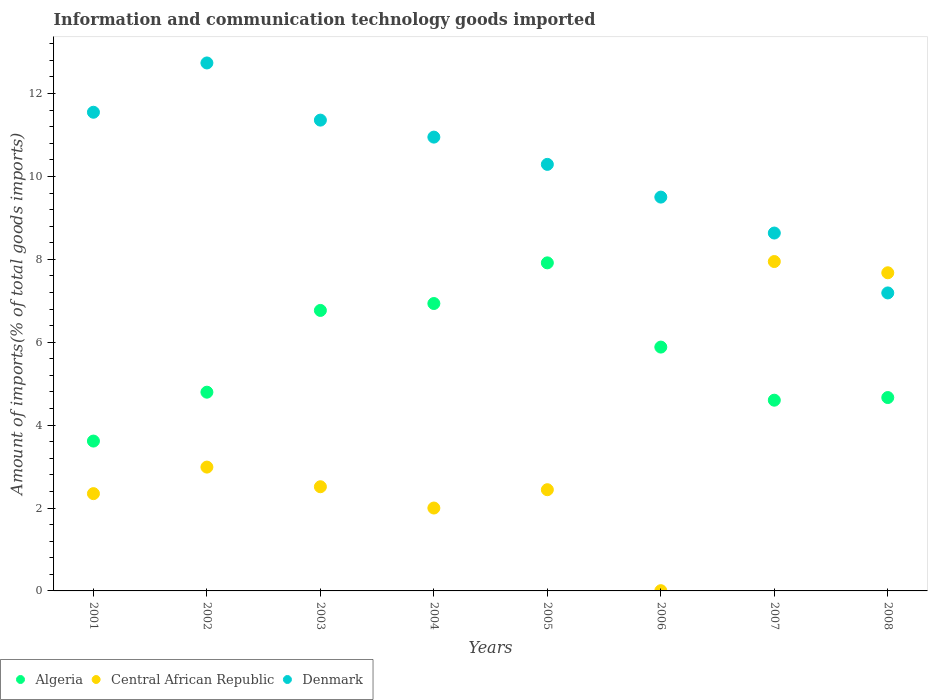How many different coloured dotlines are there?
Provide a succinct answer. 3. What is the amount of goods imported in Central African Republic in 2003?
Make the answer very short. 2.51. Across all years, what is the maximum amount of goods imported in Denmark?
Ensure brevity in your answer.  12.74. Across all years, what is the minimum amount of goods imported in Denmark?
Offer a terse response. 7.19. In which year was the amount of goods imported in Denmark maximum?
Your response must be concise. 2002. What is the total amount of goods imported in Central African Republic in the graph?
Keep it short and to the point. 27.92. What is the difference between the amount of goods imported in Denmark in 2003 and that in 2007?
Make the answer very short. 2.72. What is the difference between the amount of goods imported in Denmark in 2006 and the amount of goods imported in Central African Republic in 2001?
Provide a short and direct response. 7.15. What is the average amount of goods imported in Algeria per year?
Your response must be concise. 5.65. In the year 2004, what is the difference between the amount of goods imported in Denmark and amount of goods imported in Central African Republic?
Your answer should be compact. 8.95. In how many years, is the amount of goods imported in Central African Republic greater than 10.4 %?
Offer a very short reply. 0. What is the ratio of the amount of goods imported in Denmark in 2004 to that in 2006?
Provide a short and direct response. 1.15. Is the amount of goods imported in Denmark in 2002 less than that in 2007?
Your answer should be very brief. No. Is the difference between the amount of goods imported in Denmark in 2006 and 2008 greater than the difference between the amount of goods imported in Central African Republic in 2006 and 2008?
Provide a short and direct response. Yes. What is the difference between the highest and the second highest amount of goods imported in Central African Republic?
Make the answer very short. 0.27. What is the difference between the highest and the lowest amount of goods imported in Algeria?
Your answer should be very brief. 4.3. Is the amount of goods imported in Central African Republic strictly greater than the amount of goods imported in Algeria over the years?
Your answer should be very brief. No. Is the amount of goods imported in Algeria strictly less than the amount of goods imported in Denmark over the years?
Give a very brief answer. Yes. How many years are there in the graph?
Offer a very short reply. 8. Does the graph contain any zero values?
Your answer should be compact. No. How many legend labels are there?
Provide a succinct answer. 3. How are the legend labels stacked?
Offer a terse response. Horizontal. What is the title of the graph?
Your response must be concise. Information and communication technology goods imported. What is the label or title of the Y-axis?
Keep it short and to the point. Amount of imports(% of total goods imports). What is the Amount of imports(% of total goods imports) of Algeria in 2001?
Give a very brief answer. 3.62. What is the Amount of imports(% of total goods imports) in Central African Republic in 2001?
Offer a very short reply. 2.35. What is the Amount of imports(% of total goods imports) of Denmark in 2001?
Provide a short and direct response. 11.55. What is the Amount of imports(% of total goods imports) in Algeria in 2002?
Provide a succinct answer. 4.79. What is the Amount of imports(% of total goods imports) in Central African Republic in 2002?
Make the answer very short. 2.99. What is the Amount of imports(% of total goods imports) in Denmark in 2002?
Ensure brevity in your answer.  12.74. What is the Amount of imports(% of total goods imports) of Algeria in 2003?
Give a very brief answer. 6.77. What is the Amount of imports(% of total goods imports) in Central African Republic in 2003?
Keep it short and to the point. 2.51. What is the Amount of imports(% of total goods imports) of Denmark in 2003?
Keep it short and to the point. 11.36. What is the Amount of imports(% of total goods imports) in Algeria in 2004?
Your answer should be compact. 6.93. What is the Amount of imports(% of total goods imports) of Central African Republic in 2004?
Ensure brevity in your answer.  2. What is the Amount of imports(% of total goods imports) of Denmark in 2004?
Offer a very short reply. 10.95. What is the Amount of imports(% of total goods imports) of Algeria in 2005?
Provide a succinct answer. 7.92. What is the Amount of imports(% of total goods imports) in Central African Republic in 2005?
Give a very brief answer. 2.44. What is the Amount of imports(% of total goods imports) in Denmark in 2005?
Keep it short and to the point. 10.29. What is the Amount of imports(% of total goods imports) in Algeria in 2006?
Make the answer very short. 5.88. What is the Amount of imports(% of total goods imports) in Central African Republic in 2006?
Offer a very short reply. 0.01. What is the Amount of imports(% of total goods imports) of Denmark in 2006?
Provide a short and direct response. 9.5. What is the Amount of imports(% of total goods imports) in Algeria in 2007?
Offer a terse response. 4.6. What is the Amount of imports(% of total goods imports) of Central African Republic in 2007?
Offer a terse response. 7.95. What is the Amount of imports(% of total goods imports) of Denmark in 2007?
Your answer should be compact. 8.63. What is the Amount of imports(% of total goods imports) of Algeria in 2008?
Make the answer very short. 4.67. What is the Amount of imports(% of total goods imports) of Central African Republic in 2008?
Ensure brevity in your answer.  7.68. What is the Amount of imports(% of total goods imports) of Denmark in 2008?
Keep it short and to the point. 7.19. Across all years, what is the maximum Amount of imports(% of total goods imports) of Algeria?
Ensure brevity in your answer.  7.92. Across all years, what is the maximum Amount of imports(% of total goods imports) in Central African Republic?
Offer a terse response. 7.95. Across all years, what is the maximum Amount of imports(% of total goods imports) of Denmark?
Your answer should be very brief. 12.74. Across all years, what is the minimum Amount of imports(% of total goods imports) of Algeria?
Make the answer very short. 3.62. Across all years, what is the minimum Amount of imports(% of total goods imports) in Central African Republic?
Your answer should be compact. 0.01. Across all years, what is the minimum Amount of imports(% of total goods imports) of Denmark?
Your answer should be very brief. 7.19. What is the total Amount of imports(% of total goods imports) in Algeria in the graph?
Ensure brevity in your answer.  45.18. What is the total Amount of imports(% of total goods imports) of Central African Republic in the graph?
Offer a terse response. 27.92. What is the total Amount of imports(% of total goods imports) in Denmark in the graph?
Your response must be concise. 82.21. What is the difference between the Amount of imports(% of total goods imports) in Algeria in 2001 and that in 2002?
Make the answer very short. -1.18. What is the difference between the Amount of imports(% of total goods imports) in Central African Republic in 2001 and that in 2002?
Ensure brevity in your answer.  -0.64. What is the difference between the Amount of imports(% of total goods imports) of Denmark in 2001 and that in 2002?
Keep it short and to the point. -1.19. What is the difference between the Amount of imports(% of total goods imports) of Algeria in 2001 and that in 2003?
Your answer should be compact. -3.15. What is the difference between the Amount of imports(% of total goods imports) in Central African Republic in 2001 and that in 2003?
Offer a very short reply. -0.17. What is the difference between the Amount of imports(% of total goods imports) of Denmark in 2001 and that in 2003?
Provide a succinct answer. 0.19. What is the difference between the Amount of imports(% of total goods imports) in Algeria in 2001 and that in 2004?
Make the answer very short. -3.32. What is the difference between the Amount of imports(% of total goods imports) of Central African Republic in 2001 and that in 2004?
Offer a terse response. 0.35. What is the difference between the Amount of imports(% of total goods imports) in Denmark in 2001 and that in 2004?
Your response must be concise. 0.6. What is the difference between the Amount of imports(% of total goods imports) of Algeria in 2001 and that in 2005?
Keep it short and to the point. -4.3. What is the difference between the Amount of imports(% of total goods imports) of Central African Republic in 2001 and that in 2005?
Ensure brevity in your answer.  -0.09. What is the difference between the Amount of imports(% of total goods imports) of Denmark in 2001 and that in 2005?
Your response must be concise. 1.26. What is the difference between the Amount of imports(% of total goods imports) in Algeria in 2001 and that in 2006?
Your answer should be very brief. -2.27. What is the difference between the Amount of imports(% of total goods imports) of Central African Republic in 2001 and that in 2006?
Keep it short and to the point. 2.34. What is the difference between the Amount of imports(% of total goods imports) in Denmark in 2001 and that in 2006?
Your answer should be very brief. 2.05. What is the difference between the Amount of imports(% of total goods imports) of Algeria in 2001 and that in 2007?
Offer a very short reply. -0.99. What is the difference between the Amount of imports(% of total goods imports) of Central African Republic in 2001 and that in 2007?
Ensure brevity in your answer.  -5.6. What is the difference between the Amount of imports(% of total goods imports) in Denmark in 2001 and that in 2007?
Make the answer very short. 2.91. What is the difference between the Amount of imports(% of total goods imports) in Algeria in 2001 and that in 2008?
Offer a terse response. -1.05. What is the difference between the Amount of imports(% of total goods imports) of Central African Republic in 2001 and that in 2008?
Offer a very short reply. -5.33. What is the difference between the Amount of imports(% of total goods imports) in Denmark in 2001 and that in 2008?
Make the answer very short. 4.36. What is the difference between the Amount of imports(% of total goods imports) in Algeria in 2002 and that in 2003?
Offer a very short reply. -1.97. What is the difference between the Amount of imports(% of total goods imports) in Central African Republic in 2002 and that in 2003?
Keep it short and to the point. 0.47. What is the difference between the Amount of imports(% of total goods imports) in Denmark in 2002 and that in 2003?
Offer a terse response. 1.38. What is the difference between the Amount of imports(% of total goods imports) in Algeria in 2002 and that in 2004?
Give a very brief answer. -2.14. What is the difference between the Amount of imports(% of total goods imports) in Central African Republic in 2002 and that in 2004?
Your answer should be compact. 0.99. What is the difference between the Amount of imports(% of total goods imports) in Denmark in 2002 and that in 2004?
Offer a terse response. 1.79. What is the difference between the Amount of imports(% of total goods imports) of Algeria in 2002 and that in 2005?
Offer a very short reply. -3.12. What is the difference between the Amount of imports(% of total goods imports) in Central African Republic in 2002 and that in 2005?
Ensure brevity in your answer.  0.55. What is the difference between the Amount of imports(% of total goods imports) in Denmark in 2002 and that in 2005?
Provide a short and direct response. 2.45. What is the difference between the Amount of imports(% of total goods imports) of Algeria in 2002 and that in 2006?
Your answer should be compact. -1.09. What is the difference between the Amount of imports(% of total goods imports) in Central African Republic in 2002 and that in 2006?
Your answer should be very brief. 2.98. What is the difference between the Amount of imports(% of total goods imports) in Denmark in 2002 and that in 2006?
Ensure brevity in your answer.  3.24. What is the difference between the Amount of imports(% of total goods imports) in Algeria in 2002 and that in 2007?
Provide a succinct answer. 0.19. What is the difference between the Amount of imports(% of total goods imports) in Central African Republic in 2002 and that in 2007?
Ensure brevity in your answer.  -4.96. What is the difference between the Amount of imports(% of total goods imports) of Denmark in 2002 and that in 2007?
Your answer should be compact. 4.1. What is the difference between the Amount of imports(% of total goods imports) of Algeria in 2002 and that in 2008?
Ensure brevity in your answer.  0.13. What is the difference between the Amount of imports(% of total goods imports) of Central African Republic in 2002 and that in 2008?
Provide a short and direct response. -4.69. What is the difference between the Amount of imports(% of total goods imports) of Denmark in 2002 and that in 2008?
Make the answer very short. 5.55. What is the difference between the Amount of imports(% of total goods imports) of Algeria in 2003 and that in 2004?
Ensure brevity in your answer.  -0.17. What is the difference between the Amount of imports(% of total goods imports) in Central African Republic in 2003 and that in 2004?
Your answer should be very brief. 0.51. What is the difference between the Amount of imports(% of total goods imports) in Denmark in 2003 and that in 2004?
Keep it short and to the point. 0.41. What is the difference between the Amount of imports(% of total goods imports) in Algeria in 2003 and that in 2005?
Offer a very short reply. -1.15. What is the difference between the Amount of imports(% of total goods imports) in Central African Republic in 2003 and that in 2005?
Your answer should be very brief. 0.07. What is the difference between the Amount of imports(% of total goods imports) in Denmark in 2003 and that in 2005?
Your answer should be very brief. 1.07. What is the difference between the Amount of imports(% of total goods imports) in Algeria in 2003 and that in 2006?
Ensure brevity in your answer.  0.88. What is the difference between the Amount of imports(% of total goods imports) of Central African Republic in 2003 and that in 2006?
Offer a very short reply. 2.51. What is the difference between the Amount of imports(% of total goods imports) in Denmark in 2003 and that in 2006?
Ensure brevity in your answer.  1.86. What is the difference between the Amount of imports(% of total goods imports) of Algeria in 2003 and that in 2007?
Your response must be concise. 2.17. What is the difference between the Amount of imports(% of total goods imports) of Central African Republic in 2003 and that in 2007?
Give a very brief answer. -5.43. What is the difference between the Amount of imports(% of total goods imports) in Denmark in 2003 and that in 2007?
Make the answer very short. 2.72. What is the difference between the Amount of imports(% of total goods imports) of Algeria in 2003 and that in 2008?
Ensure brevity in your answer.  2.1. What is the difference between the Amount of imports(% of total goods imports) of Central African Republic in 2003 and that in 2008?
Give a very brief answer. -5.16. What is the difference between the Amount of imports(% of total goods imports) of Denmark in 2003 and that in 2008?
Make the answer very short. 4.17. What is the difference between the Amount of imports(% of total goods imports) in Algeria in 2004 and that in 2005?
Keep it short and to the point. -0.98. What is the difference between the Amount of imports(% of total goods imports) of Central African Republic in 2004 and that in 2005?
Keep it short and to the point. -0.44. What is the difference between the Amount of imports(% of total goods imports) of Denmark in 2004 and that in 2005?
Offer a very short reply. 0.66. What is the difference between the Amount of imports(% of total goods imports) of Algeria in 2004 and that in 2006?
Ensure brevity in your answer.  1.05. What is the difference between the Amount of imports(% of total goods imports) in Central African Republic in 2004 and that in 2006?
Offer a very short reply. 1.99. What is the difference between the Amount of imports(% of total goods imports) in Denmark in 2004 and that in 2006?
Provide a short and direct response. 1.45. What is the difference between the Amount of imports(% of total goods imports) of Algeria in 2004 and that in 2007?
Make the answer very short. 2.33. What is the difference between the Amount of imports(% of total goods imports) of Central African Republic in 2004 and that in 2007?
Your response must be concise. -5.95. What is the difference between the Amount of imports(% of total goods imports) of Denmark in 2004 and that in 2007?
Your response must be concise. 2.31. What is the difference between the Amount of imports(% of total goods imports) in Algeria in 2004 and that in 2008?
Your response must be concise. 2.27. What is the difference between the Amount of imports(% of total goods imports) in Central African Republic in 2004 and that in 2008?
Your answer should be very brief. -5.68. What is the difference between the Amount of imports(% of total goods imports) of Denmark in 2004 and that in 2008?
Offer a very short reply. 3.76. What is the difference between the Amount of imports(% of total goods imports) in Algeria in 2005 and that in 2006?
Ensure brevity in your answer.  2.03. What is the difference between the Amount of imports(% of total goods imports) in Central African Republic in 2005 and that in 2006?
Make the answer very short. 2.44. What is the difference between the Amount of imports(% of total goods imports) of Denmark in 2005 and that in 2006?
Give a very brief answer. 0.79. What is the difference between the Amount of imports(% of total goods imports) in Algeria in 2005 and that in 2007?
Your answer should be compact. 3.31. What is the difference between the Amount of imports(% of total goods imports) in Central African Republic in 2005 and that in 2007?
Provide a short and direct response. -5.51. What is the difference between the Amount of imports(% of total goods imports) in Denmark in 2005 and that in 2007?
Your answer should be very brief. 1.66. What is the difference between the Amount of imports(% of total goods imports) of Algeria in 2005 and that in 2008?
Make the answer very short. 3.25. What is the difference between the Amount of imports(% of total goods imports) of Central African Republic in 2005 and that in 2008?
Give a very brief answer. -5.23. What is the difference between the Amount of imports(% of total goods imports) of Denmark in 2005 and that in 2008?
Offer a very short reply. 3.1. What is the difference between the Amount of imports(% of total goods imports) of Algeria in 2006 and that in 2007?
Ensure brevity in your answer.  1.28. What is the difference between the Amount of imports(% of total goods imports) of Central African Republic in 2006 and that in 2007?
Make the answer very short. -7.94. What is the difference between the Amount of imports(% of total goods imports) of Denmark in 2006 and that in 2007?
Make the answer very short. 0.87. What is the difference between the Amount of imports(% of total goods imports) of Algeria in 2006 and that in 2008?
Give a very brief answer. 1.22. What is the difference between the Amount of imports(% of total goods imports) in Central African Republic in 2006 and that in 2008?
Offer a terse response. -7.67. What is the difference between the Amount of imports(% of total goods imports) in Denmark in 2006 and that in 2008?
Your response must be concise. 2.31. What is the difference between the Amount of imports(% of total goods imports) of Algeria in 2007 and that in 2008?
Your answer should be compact. -0.06. What is the difference between the Amount of imports(% of total goods imports) of Central African Republic in 2007 and that in 2008?
Your answer should be very brief. 0.27. What is the difference between the Amount of imports(% of total goods imports) in Denmark in 2007 and that in 2008?
Make the answer very short. 1.44. What is the difference between the Amount of imports(% of total goods imports) in Algeria in 2001 and the Amount of imports(% of total goods imports) in Central African Republic in 2002?
Keep it short and to the point. 0.63. What is the difference between the Amount of imports(% of total goods imports) of Algeria in 2001 and the Amount of imports(% of total goods imports) of Denmark in 2002?
Keep it short and to the point. -9.12. What is the difference between the Amount of imports(% of total goods imports) of Central African Republic in 2001 and the Amount of imports(% of total goods imports) of Denmark in 2002?
Ensure brevity in your answer.  -10.39. What is the difference between the Amount of imports(% of total goods imports) in Algeria in 2001 and the Amount of imports(% of total goods imports) in Central African Republic in 2003?
Offer a very short reply. 1.1. What is the difference between the Amount of imports(% of total goods imports) of Algeria in 2001 and the Amount of imports(% of total goods imports) of Denmark in 2003?
Give a very brief answer. -7.74. What is the difference between the Amount of imports(% of total goods imports) of Central African Republic in 2001 and the Amount of imports(% of total goods imports) of Denmark in 2003?
Your answer should be very brief. -9.01. What is the difference between the Amount of imports(% of total goods imports) of Algeria in 2001 and the Amount of imports(% of total goods imports) of Central African Republic in 2004?
Offer a terse response. 1.62. What is the difference between the Amount of imports(% of total goods imports) in Algeria in 2001 and the Amount of imports(% of total goods imports) in Denmark in 2004?
Offer a very short reply. -7.33. What is the difference between the Amount of imports(% of total goods imports) in Central African Republic in 2001 and the Amount of imports(% of total goods imports) in Denmark in 2004?
Your answer should be compact. -8.6. What is the difference between the Amount of imports(% of total goods imports) in Algeria in 2001 and the Amount of imports(% of total goods imports) in Central African Republic in 2005?
Provide a short and direct response. 1.17. What is the difference between the Amount of imports(% of total goods imports) of Algeria in 2001 and the Amount of imports(% of total goods imports) of Denmark in 2005?
Keep it short and to the point. -6.68. What is the difference between the Amount of imports(% of total goods imports) of Central African Republic in 2001 and the Amount of imports(% of total goods imports) of Denmark in 2005?
Provide a short and direct response. -7.94. What is the difference between the Amount of imports(% of total goods imports) in Algeria in 2001 and the Amount of imports(% of total goods imports) in Central African Republic in 2006?
Offer a very short reply. 3.61. What is the difference between the Amount of imports(% of total goods imports) of Algeria in 2001 and the Amount of imports(% of total goods imports) of Denmark in 2006?
Your response must be concise. -5.89. What is the difference between the Amount of imports(% of total goods imports) of Central African Republic in 2001 and the Amount of imports(% of total goods imports) of Denmark in 2006?
Provide a succinct answer. -7.15. What is the difference between the Amount of imports(% of total goods imports) of Algeria in 2001 and the Amount of imports(% of total goods imports) of Central African Republic in 2007?
Your response must be concise. -4.33. What is the difference between the Amount of imports(% of total goods imports) of Algeria in 2001 and the Amount of imports(% of total goods imports) of Denmark in 2007?
Keep it short and to the point. -5.02. What is the difference between the Amount of imports(% of total goods imports) of Central African Republic in 2001 and the Amount of imports(% of total goods imports) of Denmark in 2007?
Offer a terse response. -6.29. What is the difference between the Amount of imports(% of total goods imports) in Algeria in 2001 and the Amount of imports(% of total goods imports) in Central African Republic in 2008?
Your answer should be compact. -4.06. What is the difference between the Amount of imports(% of total goods imports) in Algeria in 2001 and the Amount of imports(% of total goods imports) in Denmark in 2008?
Give a very brief answer. -3.57. What is the difference between the Amount of imports(% of total goods imports) of Central African Republic in 2001 and the Amount of imports(% of total goods imports) of Denmark in 2008?
Provide a short and direct response. -4.84. What is the difference between the Amount of imports(% of total goods imports) of Algeria in 2002 and the Amount of imports(% of total goods imports) of Central African Republic in 2003?
Offer a very short reply. 2.28. What is the difference between the Amount of imports(% of total goods imports) in Algeria in 2002 and the Amount of imports(% of total goods imports) in Denmark in 2003?
Your answer should be very brief. -6.56. What is the difference between the Amount of imports(% of total goods imports) of Central African Republic in 2002 and the Amount of imports(% of total goods imports) of Denmark in 2003?
Your answer should be compact. -8.37. What is the difference between the Amount of imports(% of total goods imports) in Algeria in 2002 and the Amount of imports(% of total goods imports) in Central African Republic in 2004?
Your answer should be compact. 2.79. What is the difference between the Amount of imports(% of total goods imports) of Algeria in 2002 and the Amount of imports(% of total goods imports) of Denmark in 2004?
Offer a terse response. -6.15. What is the difference between the Amount of imports(% of total goods imports) of Central African Republic in 2002 and the Amount of imports(% of total goods imports) of Denmark in 2004?
Your answer should be compact. -7.96. What is the difference between the Amount of imports(% of total goods imports) in Algeria in 2002 and the Amount of imports(% of total goods imports) in Central African Republic in 2005?
Provide a short and direct response. 2.35. What is the difference between the Amount of imports(% of total goods imports) of Algeria in 2002 and the Amount of imports(% of total goods imports) of Denmark in 2005?
Offer a terse response. -5.5. What is the difference between the Amount of imports(% of total goods imports) in Central African Republic in 2002 and the Amount of imports(% of total goods imports) in Denmark in 2005?
Ensure brevity in your answer.  -7.3. What is the difference between the Amount of imports(% of total goods imports) in Algeria in 2002 and the Amount of imports(% of total goods imports) in Central African Republic in 2006?
Offer a terse response. 4.79. What is the difference between the Amount of imports(% of total goods imports) of Algeria in 2002 and the Amount of imports(% of total goods imports) of Denmark in 2006?
Give a very brief answer. -4.71. What is the difference between the Amount of imports(% of total goods imports) in Central African Republic in 2002 and the Amount of imports(% of total goods imports) in Denmark in 2006?
Offer a terse response. -6.51. What is the difference between the Amount of imports(% of total goods imports) of Algeria in 2002 and the Amount of imports(% of total goods imports) of Central African Republic in 2007?
Provide a short and direct response. -3.15. What is the difference between the Amount of imports(% of total goods imports) in Algeria in 2002 and the Amount of imports(% of total goods imports) in Denmark in 2007?
Your response must be concise. -3.84. What is the difference between the Amount of imports(% of total goods imports) of Central African Republic in 2002 and the Amount of imports(% of total goods imports) of Denmark in 2007?
Provide a short and direct response. -5.65. What is the difference between the Amount of imports(% of total goods imports) in Algeria in 2002 and the Amount of imports(% of total goods imports) in Central African Republic in 2008?
Ensure brevity in your answer.  -2.88. What is the difference between the Amount of imports(% of total goods imports) in Algeria in 2002 and the Amount of imports(% of total goods imports) in Denmark in 2008?
Give a very brief answer. -2.39. What is the difference between the Amount of imports(% of total goods imports) of Central African Republic in 2002 and the Amount of imports(% of total goods imports) of Denmark in 2008?
Your answer should be compact. -4.2. What is the difference between the Amount of imports(% of total goods imports) of Algeria in 2003 and the Amount of imports(% of total goods imports) of Central African Republic in 2004?
Provide a succinct answer. 4.77. What is the difference between the Amount of imports(% of total goods imports) of Algeria in 2003 and the Amount of imports(% of total goods imports) of Denmark in 2004?
Keep it short and to the point. -4.18. What is the difference between the Amount of imports(% of total goods imports) in Central African Republic in 2003 and the Amount of imports(% of total goods imports) in Denmark in 2004?
Make the answer very short. -8.44. What is the difference between the Amount of imports(% of total goods imports) in Algeria in 2003 and the Amount of imports(% of total goods imports) in Central African Republic in 2005?
Keep it short and to the point. 4.33. What is the difference between the Amount of imports(% of total goods imports) in Algeria in 2003 and the Amount of imports(% of total goods imports) in Denmark in 2005?
Make the answer very short. -3.52. What is the difference between the Amount of imports(% of total goods imports) in Central African Republic in 2003 and the Amount of imports(% of total goods imports) in Denmark in 2005?
Your response must be concise. -7.78. What is the difference between the Amount of imports(% of total goods imports) of Algeria in 2003 and the Amount of imports(% of total goods imports) of Central African Republic in 2006?
Provide a short and direct response. 6.76. What is the difference between the Amount of imports(% of total goods imports) of Algeria in 2003 and the Amount of imports(% of total goods imports) of Denmark in 2006?
Offer a very short reply. -2.73. What is the difference between the Amount of imports(% of total goods imports) of Central African Republic in 2003 and the Amount of imports(% of total goods imports) of Denmark in 2006?
Make the answer very short. -6.99. What is the difference between the Amount of imports(% of total goods imports) in Algeria in 2003 and the Amount of imports(% of total goods imports) in Central African Republic in 2007?
Make the answer very short. -1.18. What is the difference between the Amount of imports(% of total goods imports) of Algeria in 2003 and the Amount of imports(% of total goods imports) of Denmark in 2007?
Your answer should be very brief. -1.87. What is the difference between the Amount of imports(% of total goods imports) of Central African Republic in 2003 and the Amount of imports(% of total goods imports) of Denmark in 2007?
Keep it short and to the point. -6.12. What is the difference between the Amount of imports(% of total goods imports) in Algeria in 2003 and the Amount of imports(% of total goods imports) in Central African Republic in 2008?
Provide a succinct answer. -0.91. What is the difference between the Amount of imports(% of total goods imports) in Algeria in 2003 and the Amount of imports(% of total goods imports) in Denmark in 2008?
Make the answer very short. -0.42. What is the difference between the Amount of imports(% of total goods imports) of Central African Republic in 2003 and the Amount of imports(% of total goods imports) of Denmark in 2008?
Offer a terse response. -4.68. What is the difference between the Amount of imports(% of total goods imports) in Algeria in 2004 and the Amount of imports(% of total goods imports) in Central African Republic in 2005?
Offer a very short reply. 4.49. What is the difference between the Amount of imports(% of total goods imports) of Algeria in 2004 and the Amount of imports(% of total goods imports) of Denmark in 2005?
Give a very brief answer. -3.36. What is the difference between the Amount of imports(% of total goods imports) of Central African Republic in 2004 and the Amount of imports(% of total goods imports) of Denmark in 2005?
Your answer should be very brief. -8.29. What is the difference between the Amount of imports(% of total goods imports) of Algeria in 2004 and the Amount of imports(% of total goods imports) of Central African Republic in 2006?
Keep it short and to the point. 6.93. What is the difference between the Amount of imports(% of total goods imports) in Algeria in 2004 and the Amount of imports(% of total goods imports) in Denmark in 2006?
Your answer should be very brief. -2.57. What is the difference between the Amount of imports(% of total goods imports) of Central African Republic in 2004 and the Amount of imports(% of total goods imports) of Denmark in 2006?
Give a very brief answer. -7.5. What is the difference between the Amount of imports(% of total goods imports) in Algeria in 2004 and the Amount of imports(% of total goods imports) in Central African Republic in 2007?
Your response must be concise. -1.01. What is the difference between the Amount of imports(% of total goods imports) in Algeria in 2004 and the Amount of imports(% of total goods imports) in Denmark in 2007?
Ensure brevity in your answer.  -1.7. What is the difference between the Amount of imports(% of total goods imports) of Central African Republic in 2004 and the Amount of imports(% of total goods imports) of Denmark in 2007?
Offer a terse response. -6.63. What is the difference between the Amount of imports(% of total goods imports) in Algeria in 2004 and the Amount of imports(% of total goods imports) in Central African Republic in 2008?
Your answer should be very brief. -0.74. What is the difference between the Amount of imports(% of total goods imports) in Algeria in 2004 and the Amount of imports(% of total goods imports) in Denmark in 2008?
Your answer should be very brief. -0.26. What is the difference between the Amount of imports(% of total goods imports) in Central African Republic in 2004 and the Amount of imports(% of total goods imports) in Denmark in 2008?
Provide a short and direct response. -5.19. What is the difference between the Amount of imports(% of total goods imports) of Algeria in 2005 and the Amount of imports(% of total goods imports) of Central African Republic in 2006?
Offer a very short reply. 7.91. What is the difference between the Amount of imports(% of total goods imports) in Algeria in 2005 and the Amount of imports(% of total goods imports) in Denmark in 2006?
Keep it short and to the point. -1.59. What is the difference between the Amount of imports(% of total goods imports) of Central African Republic in 2005 and the Amount of imports(% of total goods imports) of Denmark in 2006?
Ensure brevity in your answer.  -7.06. What is the difference between the Amount of imports(% of total goods imports) in Algeria in 2005 and the Amount of imports(% of total goods imports) in Central African Republic in 2007?
Offer a very short reply. -0.03. What is the difference between the Amount of imports(% of total goods imports) of Algeria in 2005 and the Amount of imports(% of total goods imports) of Denmark in 2007?
Provide a succinct answer. -0.72. What is the difference between the Amount of imports(% of total goods imports) in Central African Republic in 2005 and the Amount of imports(% of total goods imports) in Denmark in 2007?
Keep it short and to the point. -6.19. What is the difference between the Amount of imports(% of total goods imports) in Algeria in 2005 and the Amount of imports(% of total goods imports) in Central African Republic in 2008?
Keep it short and to the point. 0.24. What is the difference between the Amount of imports(% of total goods imports) of Algeria in 2005 and the Amount of imports(% of total goods imports) of Denmark in 2008?
Ensure brevity in your answer.  0.73. What is the difference between the Amount of imports(% of total goods imports) in Central African Republic in 2005 and the Amount of imports(% of total goods imports) in Denmark in 2008?
Your answer should be very brief. -4.75. What is the difference between the Amount of imports(% of total goods imports) in Algeria in 2006 and the Amount of imports(% of total goods imports) in Central African Republic in 2007?
Provide a succinct answer. -2.06. What is the difference between the Amount of imports(% of total goods imports) in Algeria in 2006 and the Amount of imports(% of total goods imports) in Denmark in 2007?
Offer a terse response. -2.75. What is the difference between the Amount of imports(% of total goods imports) in Central African Republic in 2006 and the Amount of imports(% of total goods imports) in Denmark in 2007?
Offer a very short reply. -8.63. What is the difference between the Amount of imports(% of total goods imports) in Algeria in 2006 and the Amount of imports(% of total goods imports) in Central African Republic in 2008?
Offer a terse response. -1.79. What is the difference between the Amount of imports(% of total goods imports) in Algeria in 2006 and the Amount of imports(% of total goods imports) in Denmark in 2008?
Provide a short and direct response. -1.31. What is the difference between the Amount of imports(% of total goods imports) in Central African Republic in 2006 and the Amount of imports(% of total goods imports) in Denmark in 2008?
Ensure brevity in your answer.  -7.18. What is the difference between the Amount of imports(% of total goods imports) of Algeria in 2007 and the Amount of imports(% of total goods imports) of Central African Republic in 2008?
Your answer should be compact. -3.07. What is the difference between the Amount of imports(% of total goods imports) in Algeria in 2007 and the Amount of imports(% of total goods imports) in Denmark in 2008?
Provide a short and direct response. -2.59. What is the difference between the Amount of imports(% of total goods imports) of Central African Republic in 2007 and the Amount of imports(% of total goods imports) of Denmark in 2008?
Your response must be concise. 0.76. What is the average Amount of imports(% of total goods imports) in Algeria per year?
Keep it short and to the point. 5.65. What is the average Amount of imports(% of total goods imports) of Central African Republic per year?
Your answer should be very brief. 3.49. What is the average Amount of imports(% of total goods imports) of Denmark per year?
Provide a succinct answer. 10.28. In the year 2001, what is the difference between the Amount of imports(% of total goods imports) of Algeria and Amount of imports(% of total goods imports) of Central African Republic?
Your answer should be compact. 1.27. In the year 2001, what is the difference between the Amount of imports(% of total goods imports) in Algeria and Amount of imports(% of total goods imports) in Denmark?
Your response must be concise. -7.93. In the year 2001, what is the difference between the Amount of imports(% of total goods imports) of Central African Republic and Amount of imports(% of total goods imports) of Denmark?
Provide a succinct answer. -9.2. In the year 2002, what is the difference between the Amount of imports(% of total goods imports) of Algeria and Amount of imports(% of total goods imports) of Central African Republic?
Your response must be concise. 1.81. In the year 2002, what is the difference between the Amount of imports(% of total goods imports) in Algeria and Amount of imports(% of total goods imports) in Denmark?
Make the answer very short. -7.94. In the year 2002, what is the difference between the Amount of imports(% of total goods imports) of Central African Republic and Amount of imports(% of total goods imports) of Denmark?
Your answer should be very brief. -9.75. In the year 2003, what is the difference between the Amount of imports(% of total goods imports) of Algeria and Amount of imports(% of total goods imports) of Central African Republic?
Offer a terse response. 4.25. In the year 2003, what is the difference between the Amount of imports(% of total goods imports) in Algeria and Amount of imports(% of total goods imports) in Denmark?
Ensure brevity in your answer.  -4.59. In the year 2003, what is the difference between the Amount of imports(% of total goods imports) of Central African Republic and Amount of imports(% of total goods imports) of Denmark?
Your answer should be very brief. -8.85. In the year 2004, what is the difference between the Amount of imports(% of total goods imports) of Algeria and Amount of imports(% of total goods imports) of Central African Republic?
Your answer should be compact. 4.93. In the year 2004, what is the difference between the Amount of imports(% of total goods imports) of Algeria and Amount of imports(% of total goods imports) of Denmark?
Offer a terse response. -4.01. In the year 2004, what is the difference between the Amount of imports(% of total goods imports) in Central African Republic and Amount of imports(% of total goods imports) in Denmark?
Your response must be concise. -8.95. In the year 2005, what is the difference between the Amount of imports(% of total goods imports) of Algeria and Amount of imports(% of total goods imports) of Central African Republic?
Ensure brevity in your answer.  5.47. In the year 2005, what is the difference between the Amount of imports(% of total goods imports) in Algeria and Amount of imports(% of total goods imports) in Denmark?
Your answer should be compact. -2.38. In the year 2005, what is the difference between the Amount of imports(% of total goods imports) in Central African Republic and Amount of imports(% of total goods imports) in Denmark?
Your answer should be compact. -7.85. In the year 2006, what is the difference between the Amount of imports(% of total goods imports) in Algeria and Amount of imports(% of total goods imports) in Central African Republic?
Provide a short and direct response. 5.88. In the year 2006, what is the difference between the Amount of imports(% of total goods imports) in Algeria and Amount of imports(% of total goods imports) in Denmark?
Offer a very short reply. -3.62. In the year 2006, what is the difference between the Amount of imports(% of total goods imports) of Central African Republic and Amount of imports(% of total goods imports) of Denmark?
Give a very brief answer. -9.5. In the year 2007, what is the difference between the Amount of imports(% of total goods imports) of Algeria and Amount of imports(% of total goods imports) of Central African Republic?
Provide a short and direct response. -3.35. In the year 2007, what is the difference between the Amount of imports(% of total goods imports) in Algeria and Amount of imports(% of total goods imports) in Denmark?
Your response must be concise. -4.03. In the year 2007, what is the difference between the Amount of imports(% of total goods imports) of Central African Republic and Amount of imports(% of total goods imports) of Denmark?
Provide a short and direct response. -0.69. In the year 2008, what is the difference between the Amount of imports(% of total goods imports) in Algeria and Amount of imports(% of total goods imports) in Central African Republic?
Give a very brief answer. -3.01. In the year 2008, what is the difference between the Amount of imports(% of total goods imports) of Algeria and Amount of imports(% of total goods imports) of Denmark?
Give a very brief answer. -2.52. In the year 2008, what is the difference between the Amount of imports(% of total goods imports) of Central African Republic and Amount of imports(% of total goods imports) of Denmark?
Provide a succinct answer. 0.49. What is the ratio of the Amount of imports(% of total goods imports) in Algeria in 2001 to that in 2002?
Your response must be concise. 0.75. What is the ratio of the Amount of imports(% of total goods imports) of Central African Republic in 2001 to that in 2002?
Your response must be concise. 0.79. What is the ratio of the Amount of imports(% of total goods imports) of Denmark in 2001 to that in 2002?
Your answer should be very brief. 0.91. What is the ratio of the Amount of imports(% of total goods imports) of Algeria in 2001 to that in 2003?
Your answer should be compact. 0.53. What is the ratio of the Amount of imports(% of total goods imports) in Central African Republic in 2001 to that in 2003?
Your answer should be very brief. 0.93. What is the ratio of the Amount of imports(% of total goods imports) of Denmark in 2001 to that in 2003?
Ensure brevity in your answer.  1.02. What is the ratio of the Amount of imports(% of total goods imports) in Algeria in 2001 to that in 2004?
Give a very brief answer. 0.52. What is the ratio of the Amount of imports(% of total goods imports) of Central African Republic in 2001 to that in 2004?
Keep it short and to the point. 1.17. What is the ratio of the Amount of imports(% of total goods imports) in Denmark in 2001 to that in 2004?
Provide a succinct answer. 1.05. What is the ratio of the Amount of imports(% of total goods imports) of Algeria in 2001 to that in 2005?
Make the answer very short. 0.46. What is the ratio of the Amount of imports(% of total goods imports) in Central African Republic in 2001 to that in 2005?
Offer a terse response. 0.96. What is the ratio of the Amount of imports(% of total goods imports) of Denmark in 2001 to that in 2005?
Offer a very short reply. 1.12. What is the ratio of the Amount of imports(% of total goods imports) in Algeria in 2001 to that in 2006?
Provide a short and direct response. 0.61. What is the ratio of the Amount of imports(% of total goods imports) in Central African Republic in 2001 to that in 2006?
Your response must be concise. 415.86. What is the ratio of the Amount of imports(% of total goods imports) of Denmark in 2001 to that in 2006?
Offer a terse response. 1.22. What is the ratio of the Amount of imports(% of total goods imports) of Algeria in 2001 to that in 2007?
Offer a very short reply. 0.79. What is the ratio of the Amount of imports(% of total goods imports) in Central African Republic in 2001 to that in 2007?
Offer a terse response. 0.3. What is the ratio of the Amount of imports(% of total goods imports) in Denmark in 2001 to that in 2007?
Keep it short and to the point. 1.34. What is the ratio of the Amount of imports(% of total goods imports) in Algeria in 2001 to that in 2008?
Make the answer very short. 0.77. What is the ratio of the Amount of imports(% of total goods imports) of Central African Republic in 2001 to that in 2008?
Provide a succinct answer. 0.31. What is the ratio of the Amount of imports(% of total goods imports) of Denmark in 2001 to that in 2008?
Make the answer very short. 1.61. What is the ratio of the Amount of imports(% of total goods imports) in Algeria in 2002 to that in 2003?
Ensure brevity in your answer.  0.71. What is the ratio of the Amount of imports(% of total goods imports) in Central African Republic in 2002 to that in 2003?
Your answer should be compact. 1.19. What is the ratio of the Amount of imports(% of total goods imports) in Denmark in 2002 to that in 2003?
Offer a terse response. 1.12. What is the ratio of the Amount of imports(% of total goods imports) of Algeria in 2002 to that in 2004?
Offer a terse response. 0.69. What is the ratio of the Amount of imports(% of total goods imports) in Central African Republic in 2002 to that in 2004?
Your answer should be very brief. 1.49. What is the ratio of the Amount of imports(% of total goods imports) of Denmark in 2002 to that in 2004?
Provide a short and direct response. 1.16. What is the ratio of the Amount of imports(% of total goods imports) of Algeria in 2002 to that in 2005?
Your answer should be very brief. 0.61. What is the ratio of the Amount of imports(% of total goods imports) of Central African Republic in 2002 to that in 2005?
Make the answer very short. 1.22. What is the ratio of the Amount of imports(% of total goods imports) of Denmark in 2002 to that in 2005?
Provide a succinct answer. 1.24. What is the ratio of the Amount of imports(% of total goods imports) in Algeria in 2002 to that in 2006?
Offer a very short reply. 0.81. What is the ratio of the Amount of imports(% of total goods imports) of Central African Republic in 2002 to that in 2006?
Make the answer very short. 529.29. What is the ratio of the Amount of imports(% of total goods imports) of Denmark in 2002 to that in 2006?
Provide a succinct answer. 1.34. What is the ratio of the Amount of imports(% of total goods imports) of Algeria in 2002 to that in 2007?
Keep it short and to the point. 1.04. What is the ratio of the Amount of imports(% of total goods imports) of Central African Republic in 2002 to that in 2007?
Your response must be concise. 0.38. What is the ratio of the Amount of imports(% of total goods imports) of Denmark in 2002 to that in 2007?
Your answer should be very brief. 1.48. What is the ratio of the Amount of imports(% of total goods imports) in Algeria in 2002 to that in 2008?
Your answer should be compact. 1.03. What is the ratio of the Amount of imports(% of total goods imports) in Central African Republic in 2002 to that in 2008?
Your answer should be compact. 0.39. What is the ratio of the Amount of imports(% of total goods imports) in Denmark in 2002 to that in 2008?
Offer a very short reply. 1.77. What is the ratio of the Amount of imports(% of total goods imports) in Algeria in 2003 to that in 2004?
Give a very brief answer. 0.98. What is the ratio of the Amount of imports(% of total goods imports) in Central African Republic in 2003 to that in 2004?
Your answer should be very brief. 1.26. What is the ratio of the Amount of imports(% of total goods imports) of Denmark in 2003 to that in 2004?
Your response must be concise. 1.04. What is the ratio of the Amount of imports(% of total goods imports) in Algeria in 2003 to that in 2005?
Keep it short and to the point. 0.85. What is the ratio of the Amount of imports(% of total goods imports) of Central African Republic in 2003 to that in 2005?
Your answer should be very brief. 1.03. What is the ratio of the Amount of imports(% of total goods imports) of Denmark in 2003 to that in 2005?
Offer a very short reply. 1.1. What is the ratio of the Amount of imports(% of total goods imports) of Algeria in 2003 to that in 2006?
Keep it short and to the point. 1.15. What is the ratio of the Amount of imports(% of total goods imports) in Central African Republic in 2003 to that in 2006?
Offer a terse response. 445.31. What is the ratio of the Amount of imports(% of total goods imports) of Denmark in 2003 to that in 2006?
Ensure brevity in your answer.  1.2. What is the ratio of the Amount of imports(% of total goods imports) of Algeria in 2003 to that in 2007?
Ensure brevity in your answer.  1.47. What is the ratio of the Amount of imports(% of total goods imports) of Central African Republic in 2003 to that in 2007?
Your response must be concise. 0.32. What is the ratio of the Amount of imports(% of total goods imports) of Denmark in 2003 to that in 2007?
Provide a short and direct response. 1.32. What is the ratio of the Amount of imports(% of total goods imports) of Algeria in 2003 to that in 2008?
Offer a very short reply. 1.45. What is the ratio of the Amount of imports(% of total goods imports) of Central African Republic in 2003 to that in 2008?
Your answer should be compact. 0.33. What is the ratio of the Amount of imports(% of total goods imports) of Denmark in 2003 to that in 2008?
Keep it short and to the point. 1.58. What is the ratio of the Amount of imports(% of total goods imports) of Algeria in 2004 to that in 2005?
Your response must be concise. 0.88. What is the ratio of the Amount of imports(% of total goods imports) in Central African Republic in 2004 to that in 2005?
Provide a succinct answer. 0.82. What is the ratio of the Amount of imports(% of total goods imports) of Denmark in 2004 to that in 2005?
Keep it short and to the point. 1.06. What is the ratio of the Amount of imports(% of total goods imports) in Algeria in 2004 to that in 2006?
Offer a terse response. 1.18. What is the ratio of the Amount of imports(% of total goods imports) of Central African Republic in 2004 to that in 2006?
Keep it short and to the point. 354.32. What is the ratio of the Amount of imports(% of total goods imports) in Denmark in 2004 to that in 2006?
Offer a terse response. 1.15. What is the ratio of the Amount of imports(% of total goods imports) of Algeria in 2004 to that in 2007?
Offer a very short reply. 1.51. What is the ratio of the Amount of imports(% of total goods imports) of Central African Republic in 2004 to that in 2007?
Provide a short and direct response. 0.25. What is the ratio of the Amount of imports(% of total goods imports) of Denmark in 2004 to that in 2007?
Your answer should be compact. 1.27. What is the ratio of the Amount of imports(% of total goods imports) in Algeria in 2004 to that in 2008?
Make the answer very short. 1.49. What is the ratio of the Amount of imports(% of total goods imports) of Central African Republic in 2004 to that in 2008?
Make the answer very short. 0.26. What is the ratio of the Amount of imports(% of total goods imports) of Denmark in 2004 to that in 2008?
Your answer should be very brief. 1.52. What is the ratio of the Amount of imports(% of total goods imports) of Algeria in 2005 to that in 2006?
Offer a very short reply. 1.35. What is the ratio of the Amount of imports(% of total goods imports) of Central African Republic in 2005 to that in 2006?
Give a very brief answer. 432.62. What is the ratio of the Amount of imports(% of total goods imports) of Denmark in 2005 to that in 2006?
Your answer should be compact. 1.08. What is the ratio of the Amount of imports(% of total goods imports) of Algeria in 2005 to that in 2007?
Your answer should be compact. 1.72. What is the ratio of the Amount of imports(% of total goods imports) of Central African Republic in 2005 to that in 2007?
Make the answer very short. 0.31. What is the ratio of the Amount of imports(% of total goods imports) in Denmark in 2005 to that in 2007?
Keep it short and to the point. 1.19. What is the ratio of the Amount of imports(% of total goods imports) in Algeria in 2005 to that in 2008?
Offer a terse response. 1.7. What is the ratio of the Amount of imports(% of total goods imports) of Central African Republic in 2005 to that in 2008?
Your response must be concise. 0.32. What is the ratio of the Amount of imports(% of total goods imports) of Denmark in 2005 to that in 2008?
Give a very brief answer. 1.43. What is the ratio of the Amount of imports(% of total goods imports) of Algeria in 2006 to that in 2007?
Make the answer very short. 1.28. What is the ratio of the Amount of imports(% of total goods imports) of Central African Republic in 2006 to that in 2007?
Your answer should be very brief. 0. What is the ratio of the Amount of imports(% of total goods imports) of Denmark in 2006 to that in 2007?
Your answer should be very brief. 1.1. What is the ratio of the Amount of imports(% of total goods imports) in Algeria in 2006 to that in 2008?
Make the answer very short. 1.26. What is the ratio of the Amount of imports(% of total goods imports) in Central African Republic in 2006 to that in 2008?
Your answer should be compact. 0. What is the ratio of the Amount of imports(% of total goods imports) in Denmark in 2006 to that in 2008?
Give a very brief answer. 1.32. What is the ratio of the Amount of imports(% of total goods imports) of Algeria in 2007 to that in 2008?
Make the answer very short. 0.99. What is the ratio of the Amount of imports(% of total goods imports) of Central African Republic in 2007 to that in 2008?
Your response must be concise. 1.04. What is the ratio of the Amount of imports(% of total goods imports) in Denmark in 2007 to that in 2008?
Your answer should be very brief. 1.2. What is the difference between the highest and the second highest Amount of imports(% of total goods imports) in Algeria?
Give a very brief answer. 0.98. What is the difference between the highest and the second highest Amount of imports(% of total goods imports) of Central African Republic?
Your response must be concise. 0.27. What is the difference between the highest and the second highest Amount of imports(% of total goods imports) of Denmark?
Your response must be concise. 1.19. What is the difference between the highest and the lowest Amount of imports(% of total goods imports) of Algeria?
Give a very brief answer. 4.3. What is the difference between the highest and the lowest Amount of imports(% of total goods imports) in Central African Republic?
Give a very brief answer. 7.94. What is the difference between the highest and the lowest Amount of imports(% of total goods imports) in Denmark?
Keep it short and to the point. 5.55. 